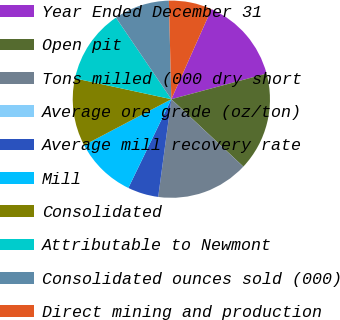Convert chart. <chart><loc_0><loc_0><loc_500><loc_500><pie_chart><fcel>Year Ended December 31<fcel>Open pit<fcel>Tons milled (000 dry short<fcel>Average ore grade (oz/ton)<fcel>Average mill recovery rate<fcel>Mill<fcel>Consolidated<fcel>Attributable to Newmont<fcel>Consolidated ounces sold (000)<fcel>Direct mining and production<nl><fcel>14.14%<fcel>16.16%<fcel>15.15%<fcel>0.0%<fcel>5.05%<fcel>10.1%<fcel>11.11%<fcel>12.12%<fcel>9.09%<fcel>7.07%<nl></chart> 